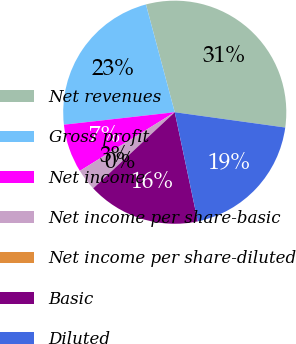Convert chart to OTSL. <chart><loc_0><loc_0><loc_500><loc_500><pie_chart><fcel>Net revenues<fcel>Gross profit<fcel>Net income<fcel>Net income per share-basic<fcel>Net income per share-diluted<fcel>Basic<fcel>Diluted<nl><fcel>31.35%<fcel>22.63%<fcel>7.03%<fcel>3.14%<fcel>0.0%<fcel>16.36%<fcel>19.5%<nl></chart> 